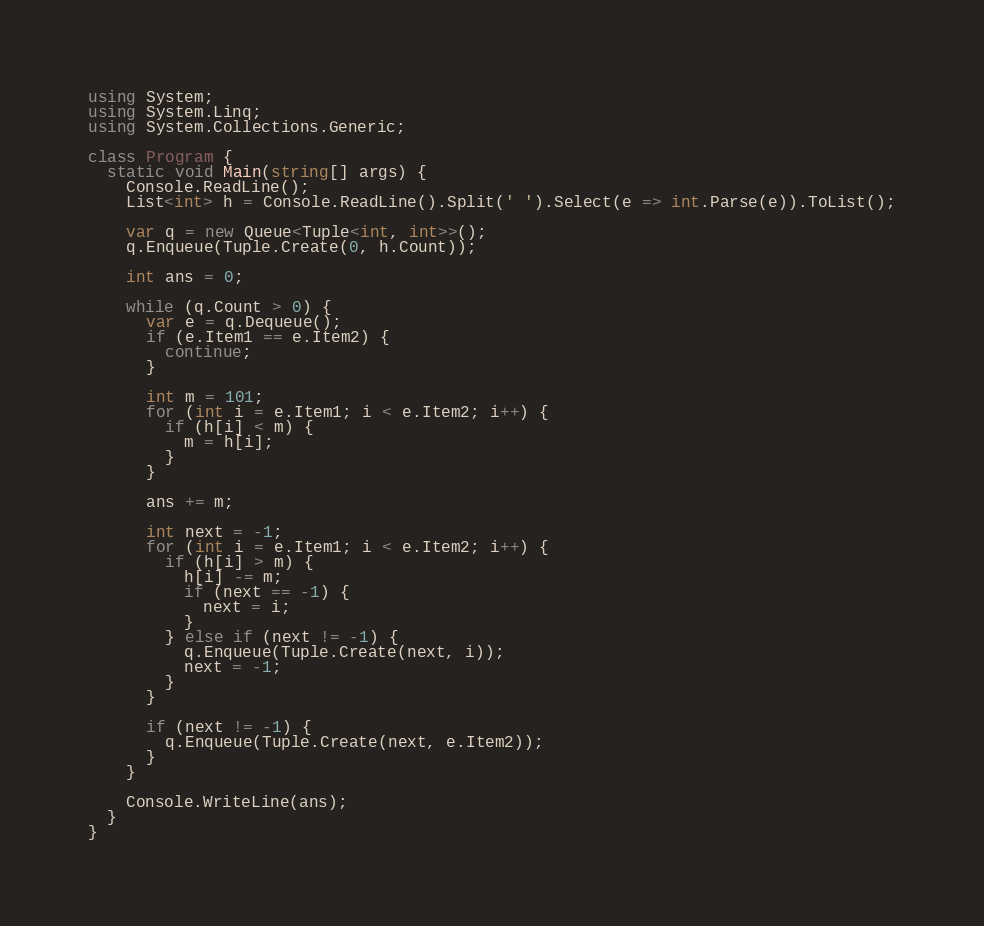Convert code to text. <code><loc_0><loc_0><loc_500><loc_500><_C#_>using System;
using System.Linq;
using System.Collections.Generic;

class Program {
  static void Main(string[] args) {
    Console.ReadLine();
    List<int> h = Console.ReadLine().Split(' ').Select(e => int.Parse(e)).ToList();

    var q = new Queue<Tuple<int, int>>();
    q.Enqueue(Tuple.Create(0, h.Count));
  
    int ans = 0;

    while (q.Count > 0) {
      var e = q.Dequeue();
      if (e.Item1 == e.Item2) {
        continue;
      }

      int m = 101;
      for (int i = e.Item1; i < e.Item2; i++) {
        if (h[i] < m) {
          m = h[i];
        } 
      }
      
      ans += m;

      int next = -1;
      for (int i = e.Item1; i < e.Item2; i++) {
        if (h[i] > m) {
          h[i] -= m;
          if (next == -1) {
            next = i;
          }
        } else if (next != -1) {
          q.Enqueue(Tuple.Create(next, i));
          next = -1;
        }
      }

      if (next != -1) {
        q.Enqueue(Tuple.Create(next, e.Item2));
      }
    }

    Console.WriteLine(ans);
  }
}
</code> 